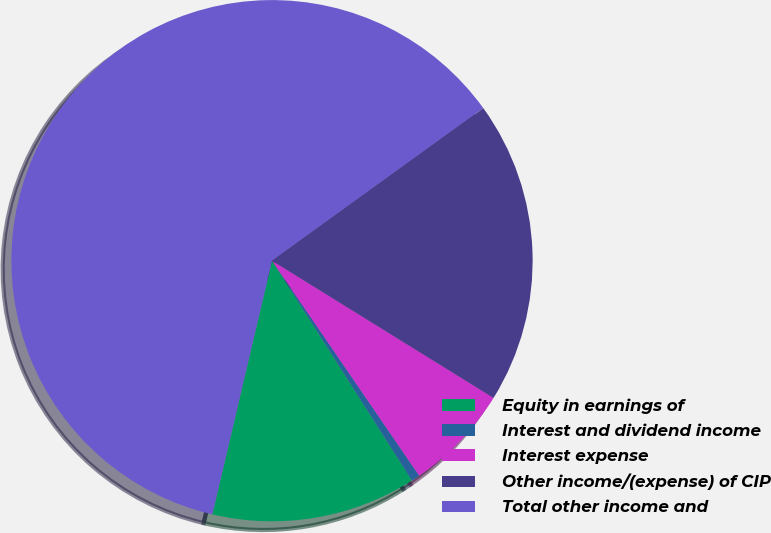Convert chart. <chart><loc_0><loc_0><loc_500><loc_500><pie_chart><fcel>Equity in earnings of<fcel>Interest and dividend income<fcel>Interest expense<fcel>Other income/(expense) of CIP<fcel>Total other income and<nl><fcel>12.7%<fcel>0.53%<fcel>6.62%<fcel>18.78%<fcel>61.37%<nl></chart> 